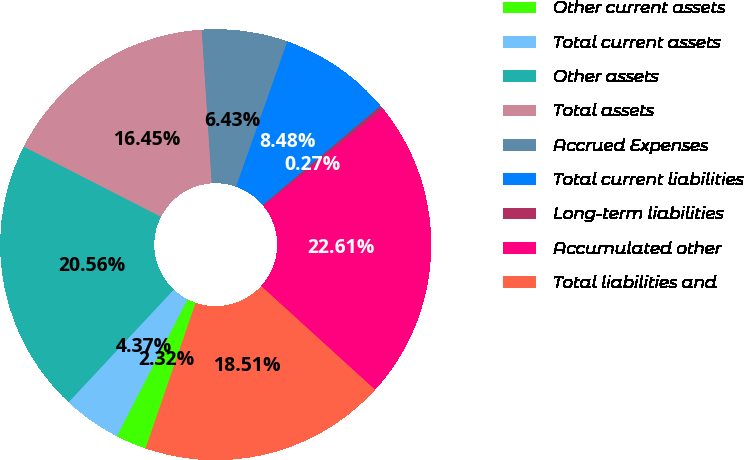Convert chart to OTSL. <chart><loc_0><loc_0><loc_500><loc_500><pie_chart><fcel>Other current assets<fcel>Total current assets<fcel>Other assets<fcel>Total assets<fcel>Accrued Expenses<fcel>Total current liabilities<fcel>Long-term liabilities<fcel>Accumulated other<fcel>Total liabilities and<nl><fcel>2.32%<fcel>4.37%<fcel>20.56%<fcel>16.45%<fcel>6.43%<fcel>8.48%<fcel>0.27%<fcel>22.61%<fcel>18.51%<nl></chart> 